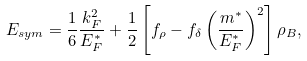Convert formula to latex. <formula><loc_0><loc_0><loc_500><loc_500>E _ { s y m } = \frac { 1 } { 6 } \frac { k _ { F } ^ { 2 } } { E _ { F } ^ { * } } + \frac { 1 } { 2 } \left [ f _ { \rho } - f _ { \delta } \left ( \frac { m ^ { * } } { E _ { F } ^ { * } } \right ) ^ { 2 } \right ] \rho _ { B } ,</formula> 